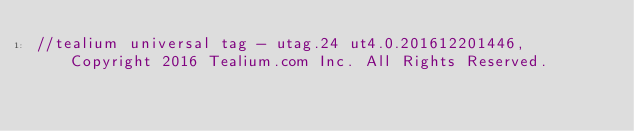Convert code to text. <code><loc_0><loc_0><loc_500><loc_500><_JavaScript_>//tealium universal tag - utag.24 ut4.0.201612201446, Copyright 2016 Tealium.com Inc. All Rights Reserved.</code> 